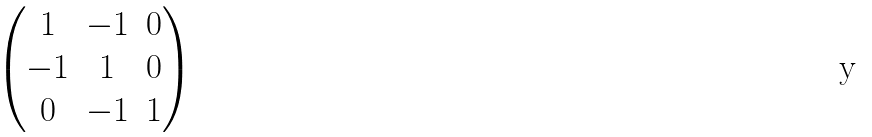<formula> <loc_0><loc_0><loc_500><loc_500>\begin{pmatrix} 1 & - 1 & 0 \\ - 1 & 1 & 0 \\ 0 & - 1 & 1 \end{pmatrix}</formula> 